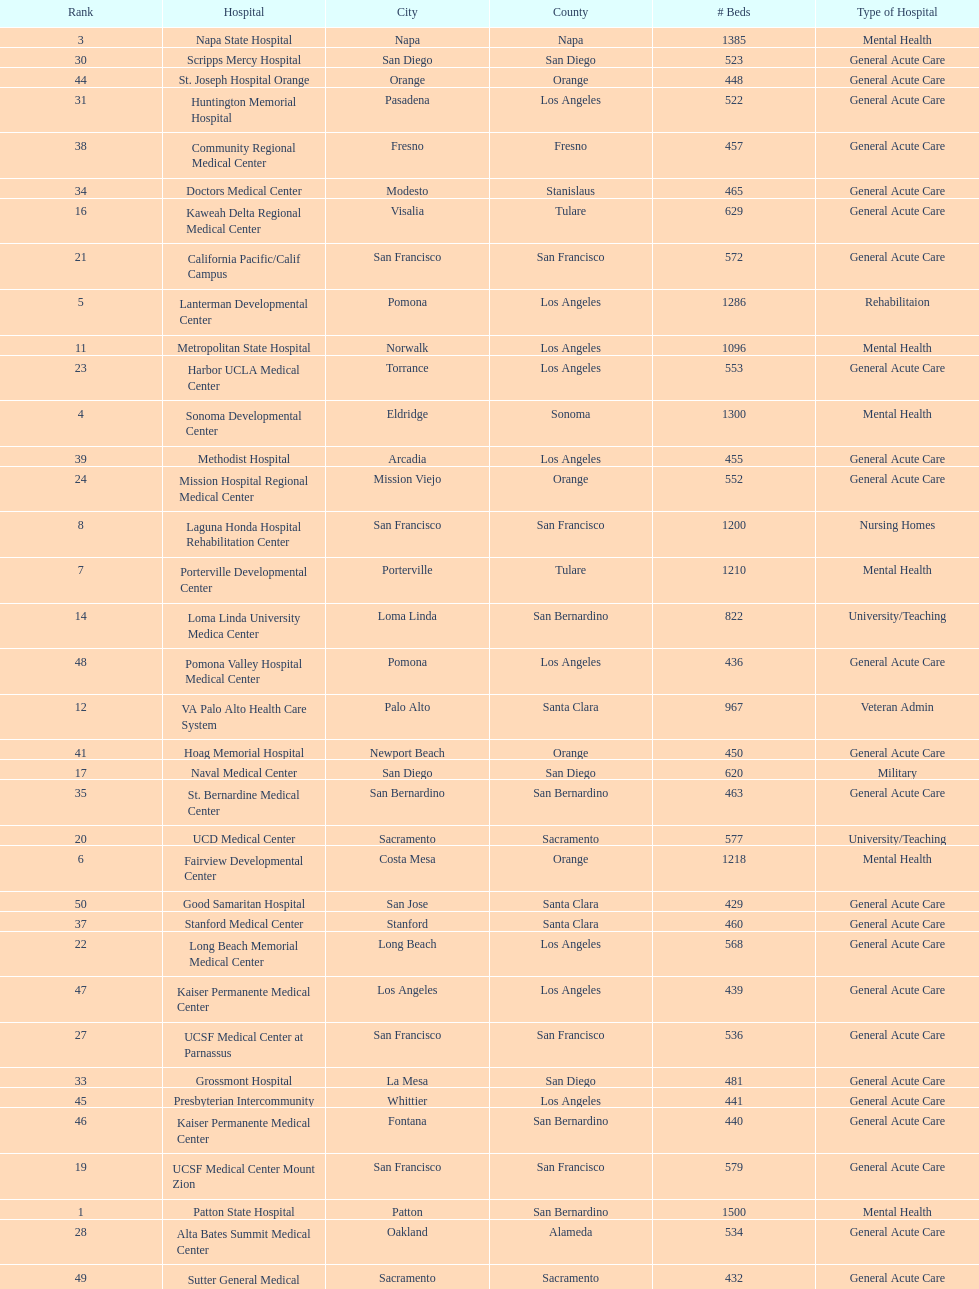How many more general acute care hospitals are there in california than rehabilitation hospitals? 33. 